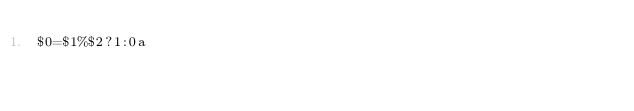<code> <loc_0><loc_0><loc_500><loc_500><_Awk_>$0=$1%$2?1:0a</code> 